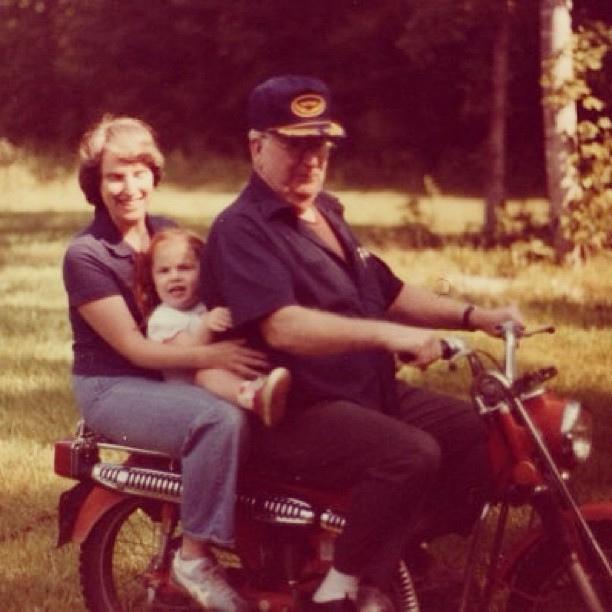Are they wearing helmets?
Short answer required. No. Is the image black and white?
Concise answer only. No. What are the people riding on?
Write a very short answer. Motorcycle. Is the little girl scared?
Keep it brief. No. 